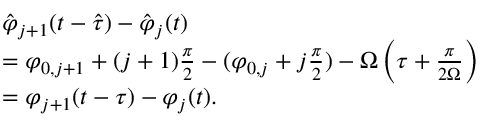<formula> <loc_0><loc_0><loc_500><loc_500>\begin{array} { r l } & { \hat { \varphi } _ { j + 1 } ( t - \hat { \tau } ) - \hat { \varphi } _ { j } ( t ) } \\ & { = \varphi _ { 0 , j + 1 } + ( j + 1 ) \frac { \pi } { 2 } - ( \varphi _ { 0 , j } + j \frac { \pi } { 2 } ) - \Omega \left ( \tau + \frac { \pi } { 2 \Omega } \right ) } \\ & { = \varphi _ { j + 1 } ( t - \tau ) - \varphi _ { j } ( t ) . } \end{array}</formula> 